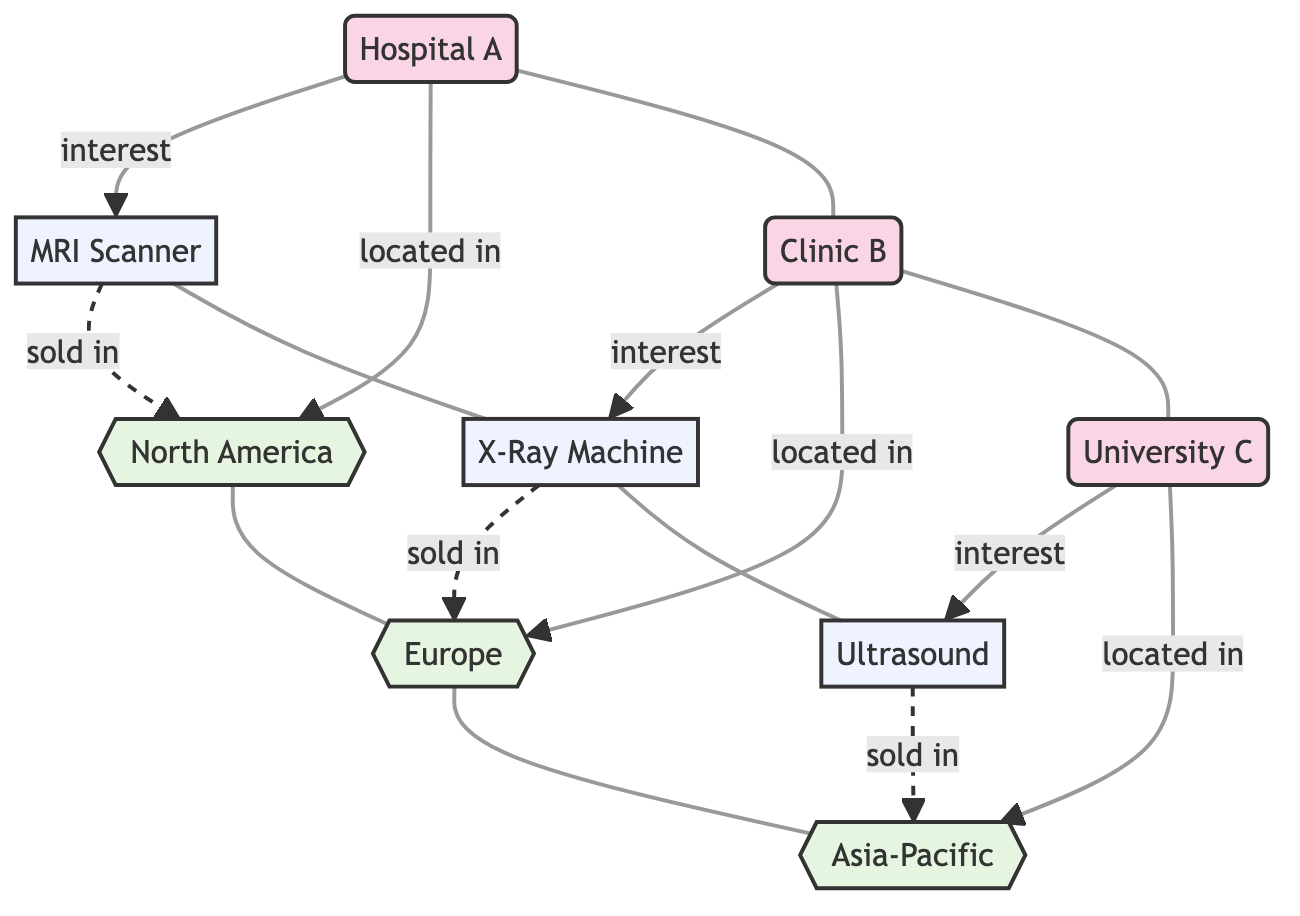What is the total number of sales leads in the diagram? The diagram contains three nodes representing sales leads: Hospital A, Clinic B, and University C. Counting these leads gives us a total of three sales leads.
Answer: 3 Which product is Hospital A interested in? The diagram shows a direct link from Hospital A to the MRI Scanner with the label "interest." This indicates that Hospital A has expressed interest in the MRI Scanner.
Answer: MRI Scanner How many regions are represented in the diagram? The diagram includes three distinct geographic regions: North America, Europe, and Asia-Pacific. Counting these regions reveals a total of three regions.
Answer: 3 What product is located in Europe? The diagram identifies a link from the X-Ray Machine to the region labeled Europe, indicating that the X-Ray Machine is associated with this region.
Answer: X-Ray Machine Which lead is associated with the Asia-Pacific region? The diagram shows a connection from University C to the Asia-Pacific region, which indicates that University C is located in this specific geographic area.
Answer: University C Are there any leads located in North America? A direct connection exists between Hospital A and the North America region, confirming that Hospital A is located in North America.
Answer: Yes What product has a connection to both the North America region and a lead? The MRI Scanner is linked to both Hospital A (the lead) and the North America region (showing that it is associated with leads in that region).
Answer: MRI Scanner Which product does Clinic B express interest in? The diagram clearly depicts a connection from Clinic B to the X-Ray Machine with the label "interest," confirming that Clinic B is interested in this product.
Answer: X-Ray Machine In total, how many connections are there between products and regions? The diagram shows three products linked to their respective regions: the MRI Scanner to North America, the X-Ray Machine to Europe, and the Ultrasound to Asia-Pacific. Thus, there are three connections between products and regions.
Answer: 3 